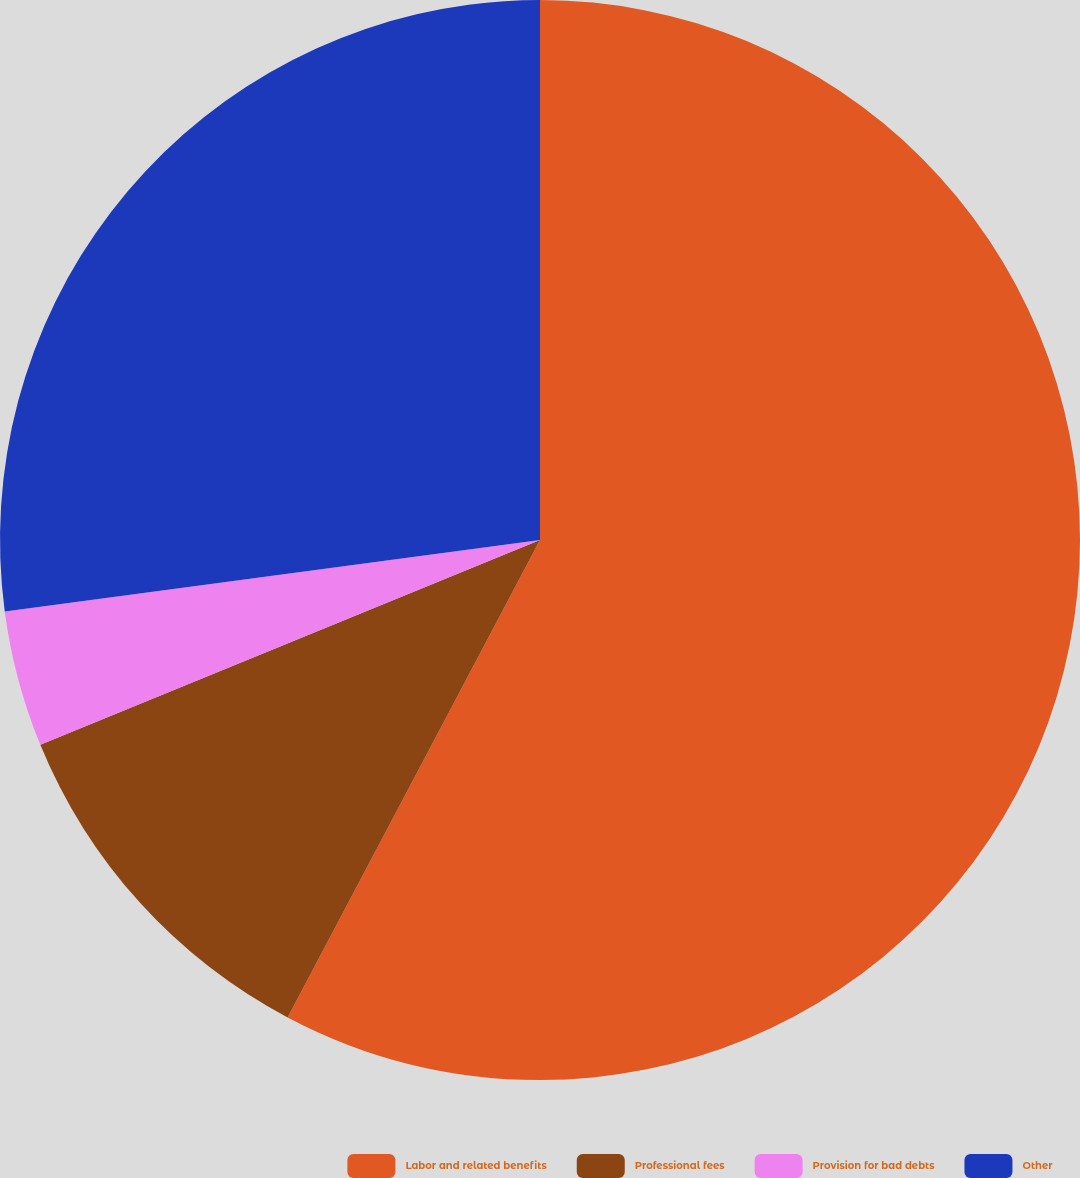Convert chart. <chart><loc_0><loc_0><loc_500><loc_500><pie_chart><fcel>Labor and related benefits<fcel>Professional fees<fcel>Provision for bad debts<fcel>Other<nl><fcel>57.74%<fcel>11.07%<fcel>4.08%<fcel>27.11%<nl></chart> 